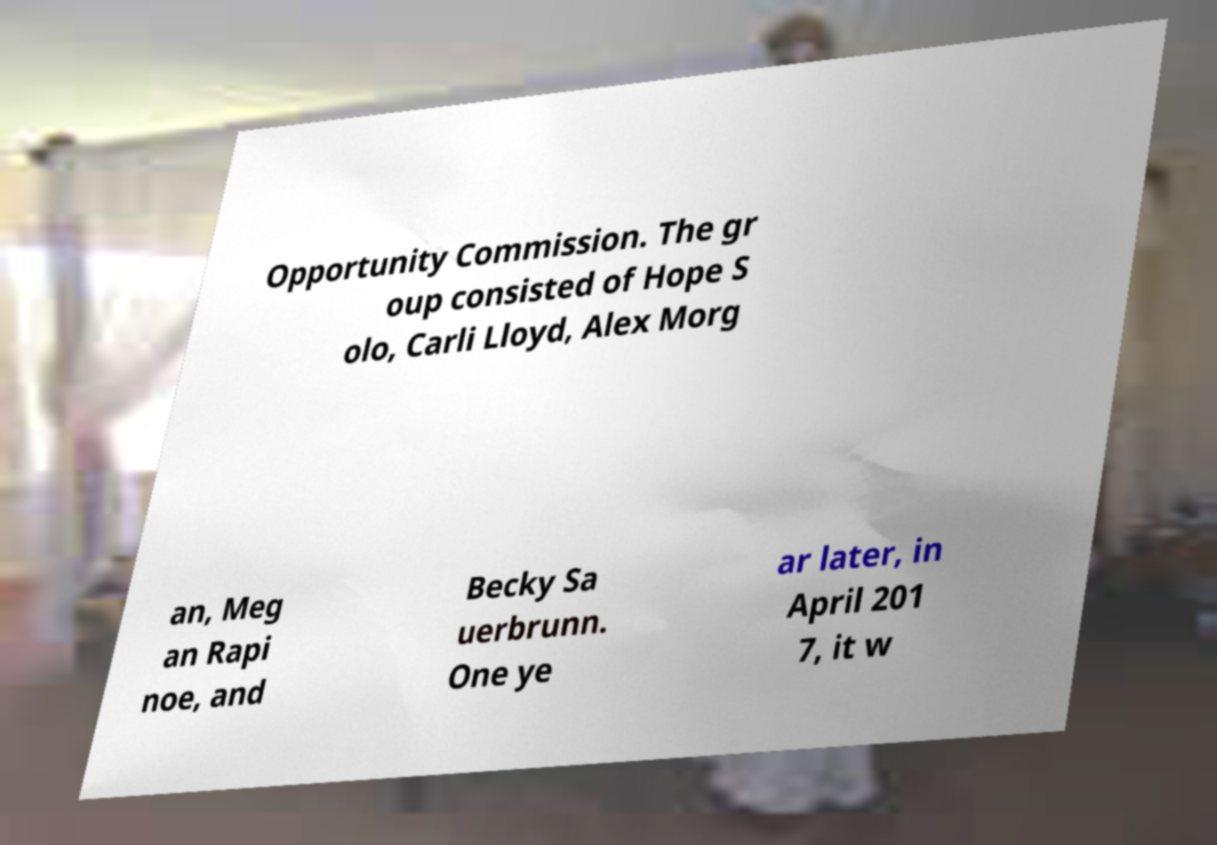Can you read and provide the text displayed in the image?This photo seems to have some interesting text. Can you extract and type it out for me? Opportunity Commission. The gr oup consisted of Hope S olo, Carli Lloyd, Alex Morg an, Meg an Rapi noe, and Becky Sa uerbrunn. One ye ar later, in April 201 7, it w 